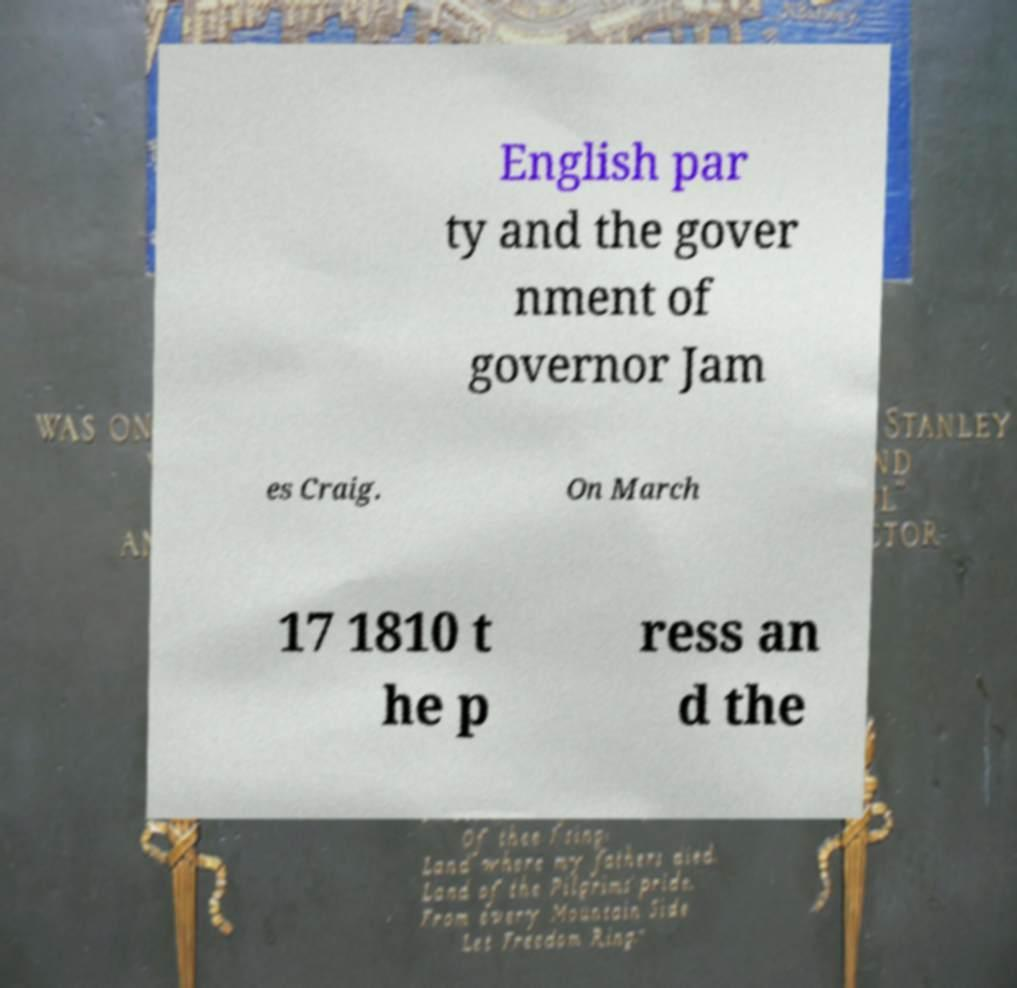What messages or text are displayed in this image? I need them in a readable, typed format. English par ty and the gover nment of governor Jam es Craig. On March 17 1810 t he p ress an d the 